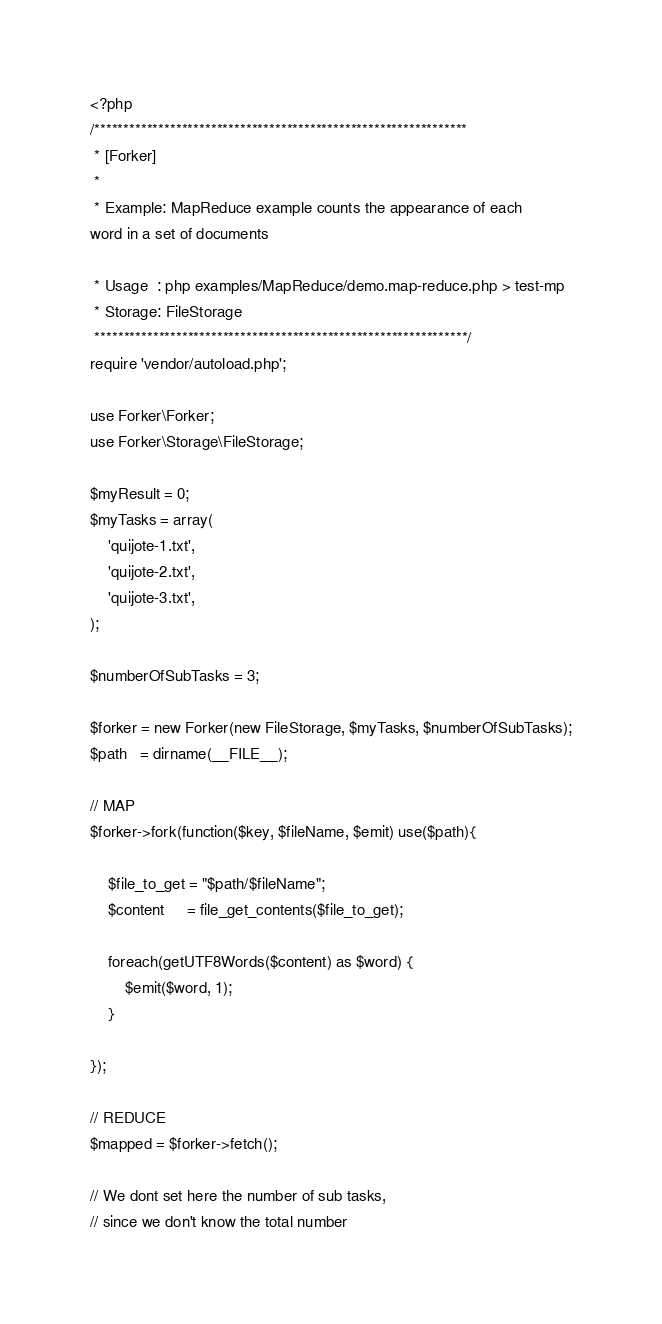<code> <loc_0><loc_0><loc_500><loc_500><_PHP_><?php
/****************************************************************
 * [Forker]
 *
 * Example: MapReduce example counts the appearance of each
word in a set of documents

 * Usage  : php examples/MapReduce/demo.map-reduce.php > test-mp
 * Storage: FileStorage
 ****************************************************************/
require 'vendor/autoload.php';

use Forker\Forker;
use Forker\Storage\FileStorage;

$myResult = 0;
$myTasks = array(
    'quijote-1.txt',
    'quijote-2.txt',
    'quijote-3.txt',
);

$numberOfSubTasks = 3;

$forker = new Forker(new FileStorage, $myTasks, $numberOfSubTasks);
$path   = dirname(__FILE__);

// MAP
$forker->fork(function($key, $fileName, $emit) use($path){

    $file_to_get = "$path/$fileName";
    $content     = file_get_contents($file_to_get);

    foreach(getUTF8Words($content) as $word) {
        $emit($word, 1);
    }

});

// REDUCE
$mapped = $forker->fetch();

// We dont set here the number of sub tasks, 
// since we don't know the total number</code> 